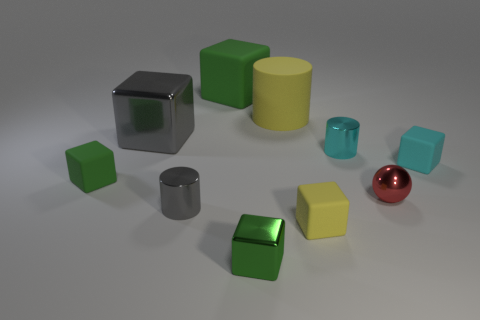What is the shape of the small matte object that is the same color as the large matte cylinder?
Your response must be concise. Cube. How many other objects are the same size as the cyan cylinder?
Provide a short and direct response. 6. Is the size of the yellow cylinder the same as the red shiny sphere that is to the right of the green metal cube?
Your answer should be compact. No. What color is the other rubber block that is the same size as the gray cube?
Your answer should be compact. Green. What is the size of the cyan rubber block?
Provide a short and direct response. Small. Is the gray object that is in front of the cyan block made of the same material as the cyan block?
Your answer should be compact. No. Is the shape of the red object the same as the tiny green rubber object?
Your answer should be compact. No. There is a yellow matte thing that is behind the green matte thing to the left of the large block that is behind the matte cylinder; what is its shape?
Your answer should be compact. Cylinder. Do the object that is behind the large yellow matte cylinder and the small shiny thing that is left of the large green thing have the same shape?
Keep it short and to the point. No. Is there a green object that has the same material as the cyan cylinder?
Offer a terse response. Yes. 